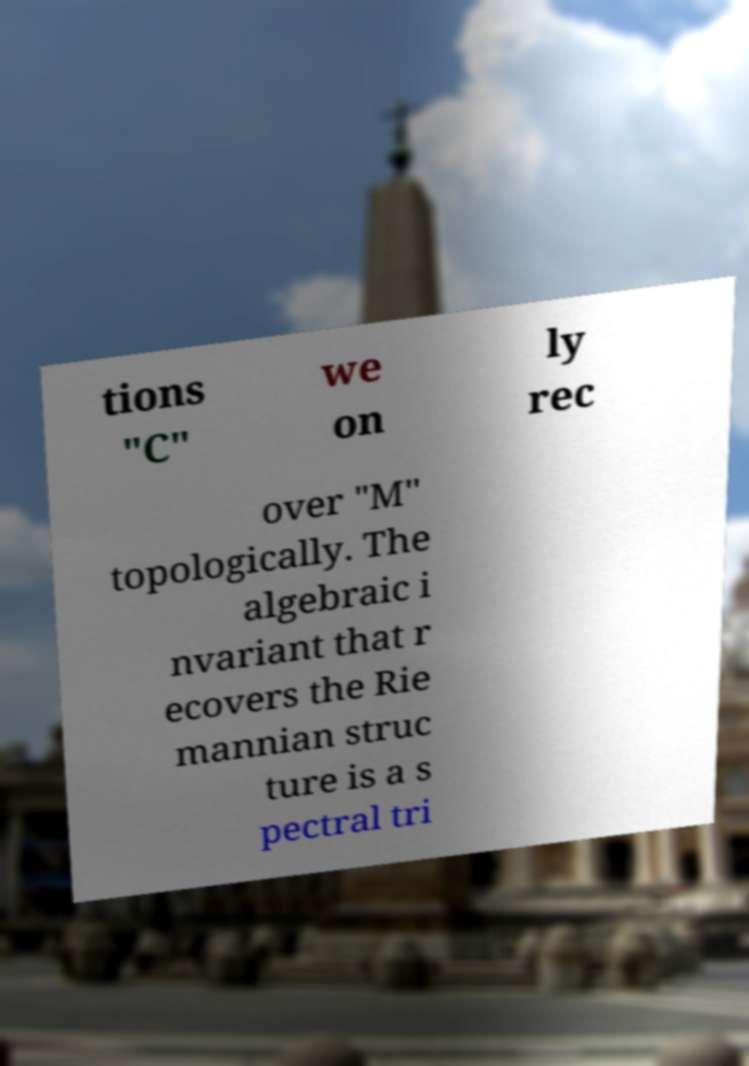There's text embedded in this image that I need extracted. Can you transcribe it verbatim? tions "C" we on ly rec over "M" topologically. The algebraic i nvariant that r ecovers the Rie mannian struc ture is a s pectral tri 